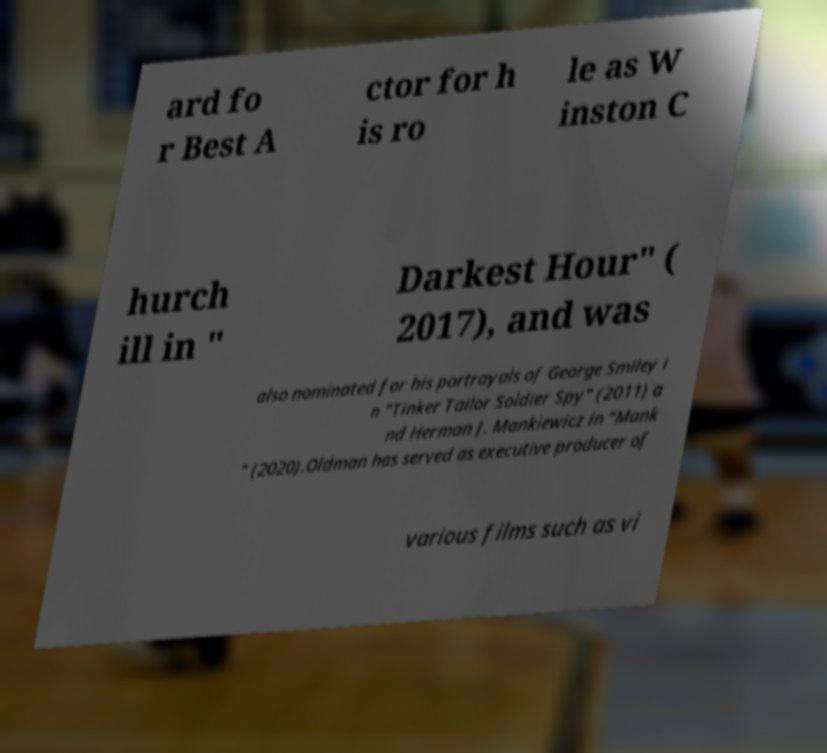What messages or text are displayed in this image? I need them in a readable, typed format. ard fo r Best A ctor for h is ro le as W inston C hurch ill in " Darkest Hour" ( 2017), and was also nominated for his portrayals of George Smiley i n "Tinker Tailor Soldier Spy" (2011) a nd Herman J. Mankiewicz in "Mank " (2020).Oldman has served as executive producer of various films such as vi 